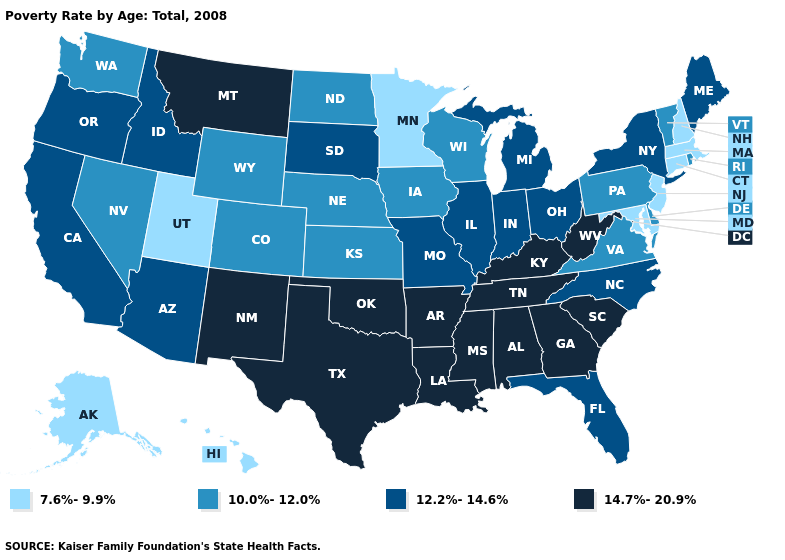What is the value of Michigan?
Be succinct. 12.2%-14.6%. What is the value of Washington?
Answer briefly. 10.0%-12.0%. Among the states that border Utah , does Colorado have the highest value?
Answer briefly. No. Name the states that have a value in the range 10.0%-12.0%?
Quick response, please. Colorado, Delaware, Iowa, Kansas, Nebraska, Nevada, North Dakota, Pennsylvania, Rhode Island, Vermont, Virginia, Washington, Wisconsin, Wyoming. Name the states that have a value in the range 7.6%-9.9%?
Keep it brief. Alaska, Connecticut, Hawaii, Maryland, Massachusetts, Minnesota, New Hampshire, New Jersey, Utah. Does Wyoming have a higher value than Massachusetts?
Keep it brief. Yes. What is the value of South Carolina?
Give a very brief answer. 14.7%-20.9%. What is the value of Montana?
Answer briefly. 14.7%-20.9%. Does the first symbol in the legend represent the smallest category?
Short answer required. Yes. What is the highest value in the USA?
Concise answer only. 14.7%-20.9%. What is the lowest value in the West?
Short answer required. 7.6%-9.9%. Does the map have missing data?
Keep it brief. No. Which states hav the highest value in the West?
Answer briefly. Montana, New Mexico. What is the highest value in states that border Oklahoma?
Answer briefly. 14.7%-20.9%. Name the states that have a value in the range 7.6%-9.9%?
Keep it brief. Alaska, Connecticut, Hawaii, Maryland, Massachusetts, Minnesota, New Hampshire, New Jersey, Utah. 